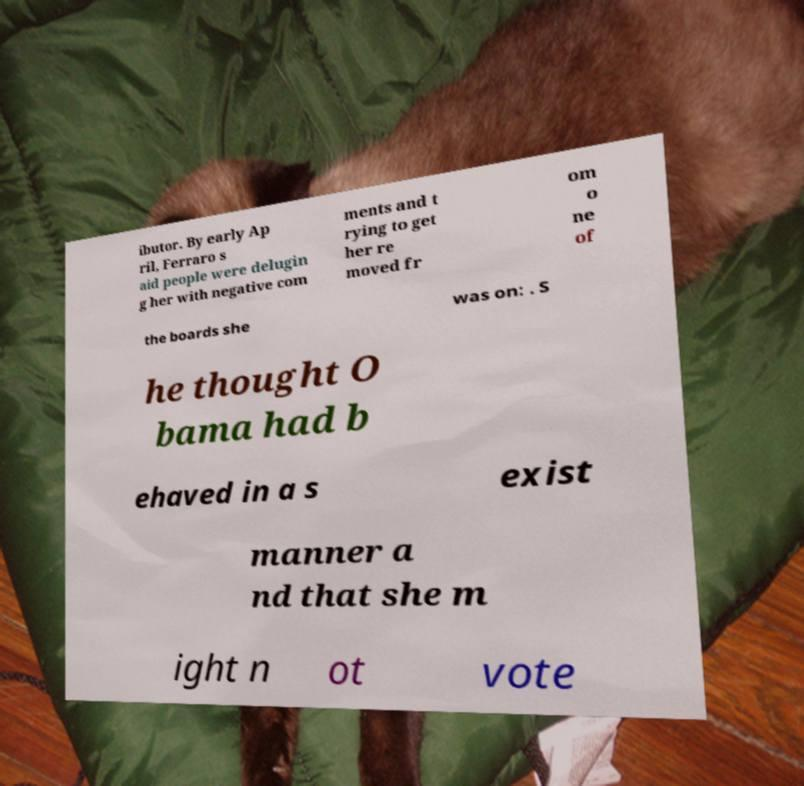What messages or text are displayed in this image? I need them in a readable, typed format. ibutor. By early Ap ril, Ferraro s aid people were delugin g her with negative com ments and t rying to get her re moved fr om o ne of the boards she was on: . S he thought O bama had b ehaved in a s exist manner a nd that she m ight n ot vote 